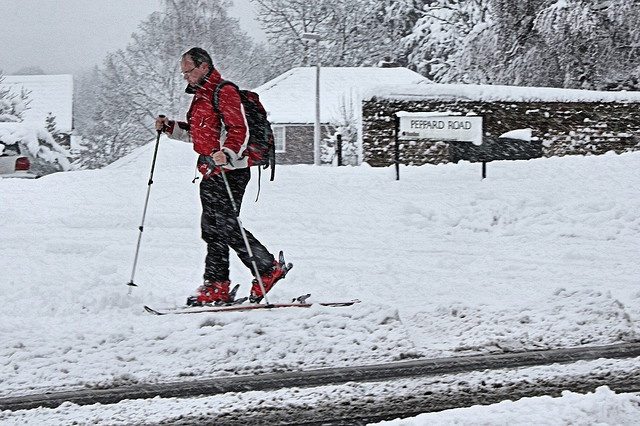Describe the objects in this image and their specific colors. I can see people in lightgray, black, maroon, and darkgray tones, backpack in lightgray, black, gray, and maroon tones, car in lightgray, darkgray, gray, and black tones, and skis in lightgray, darkgray, gray, and black tones in this image. 